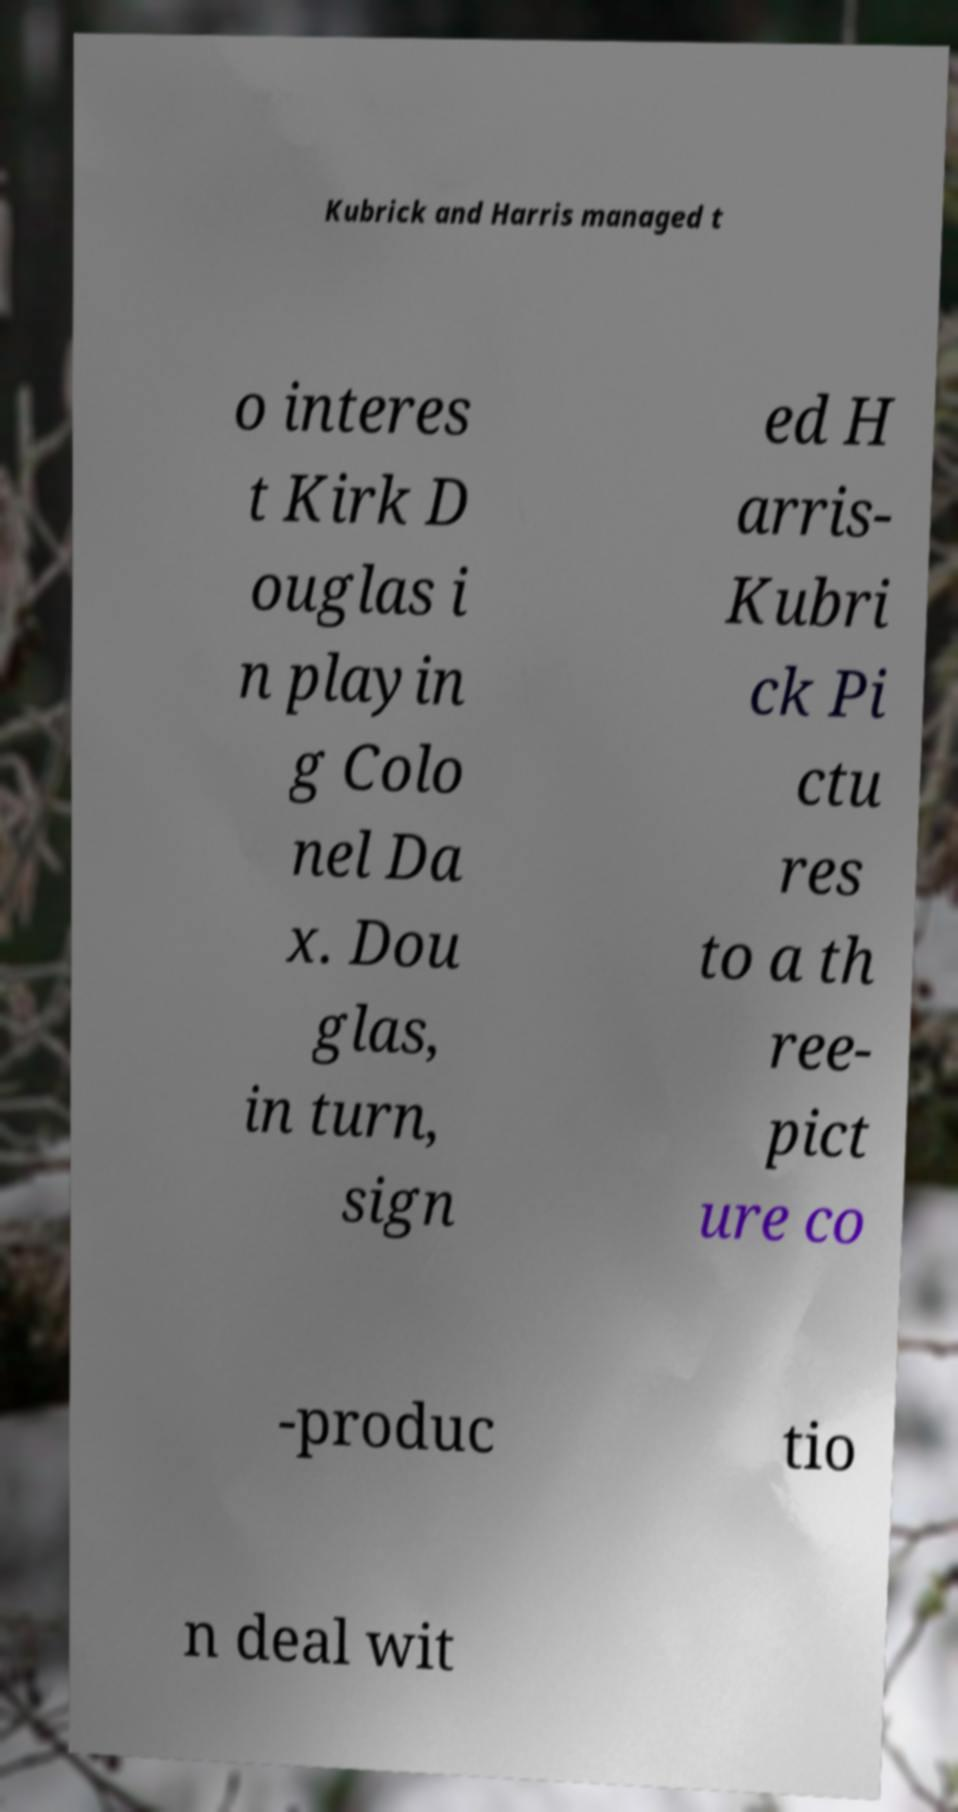Could you extract and type out the text from this image? Kubrick and Harris managed t o interes t Kirk D ouglas i n playin g Colo nel Da x. Dou glas, in turn, sign ed H arris- Kubri ck Pi ctu res to a th ree- pict ure co -produc tio n deal wit 